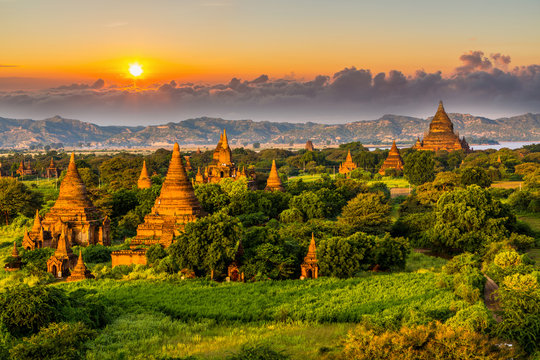Can you describe the main features of this image for me? This image offers a spectacular sunset view over Bagan, Myanmar, emphasizing the city’s ancient and religious heritage through its sea of temples and pagodas. Among these, the largest pagoda stands prominently at the center, symbolic of Bagan's historical stature as a religious and cultural hub. The setting sun casts golden hues across the structures, while the lush vegetation accentuates the rustic beauty of the area. The cloudy sky adds a dramatic yet serene backdrop, enhancing the mystical aura of this historic landscape. 